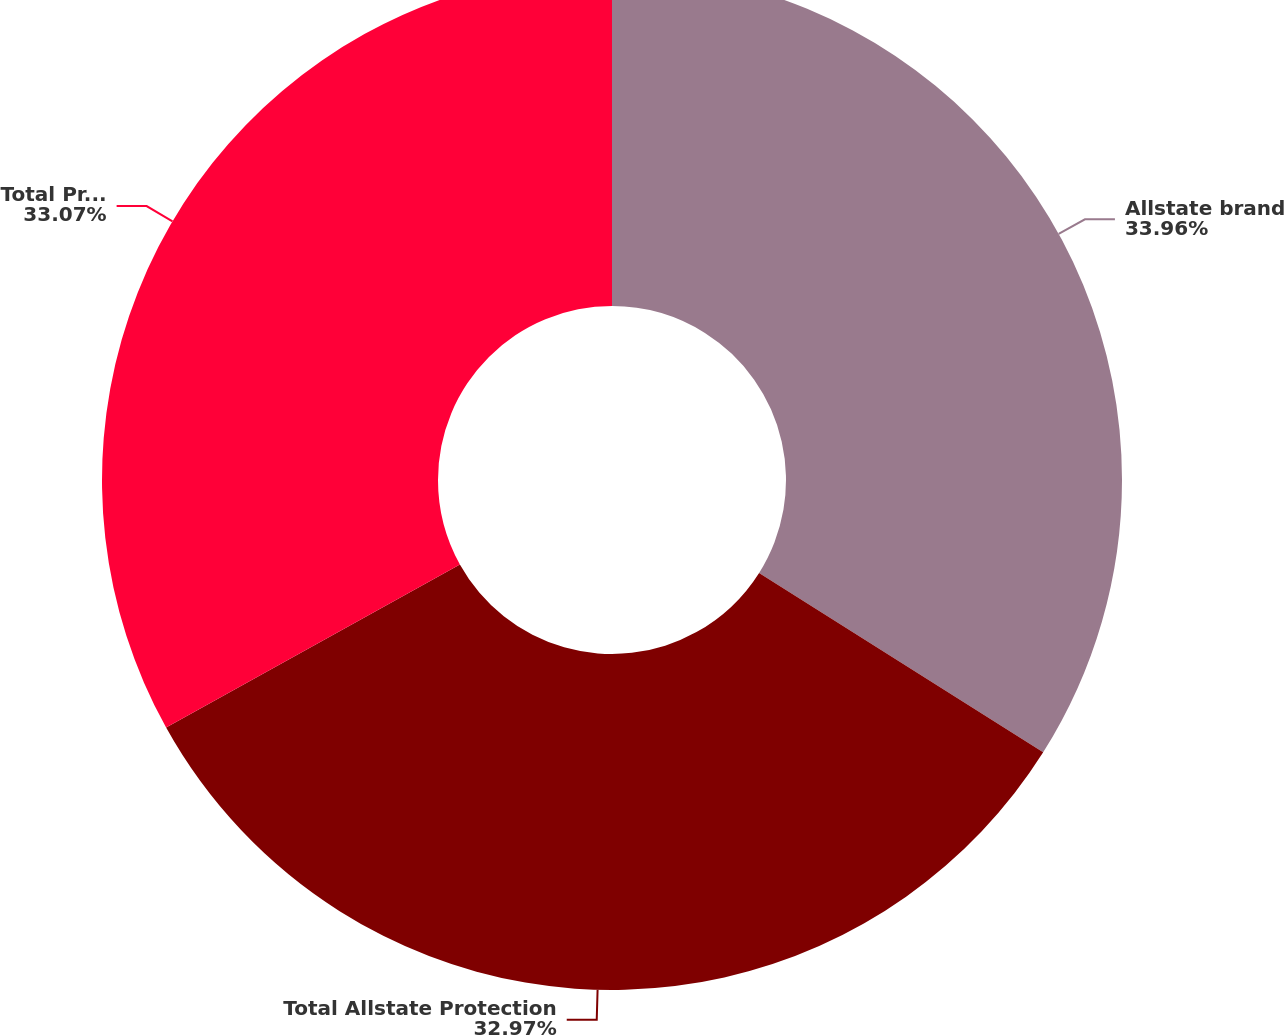Convert chart. <chart><loc_0><loc_0><loc_500><loc_500><pie_chart><fcel>Allstate brand<fcel>Total Allstate Protection<fcel>Total Property-Liability<nl><fcel>33.97%<fcel>32.97%<fcel>33.07%<nl></chart> 